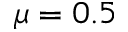Convert formula to latex. <formula><loc_0><loc_0><loc_500><loc_500>\mu = 0 . 5</formula> 